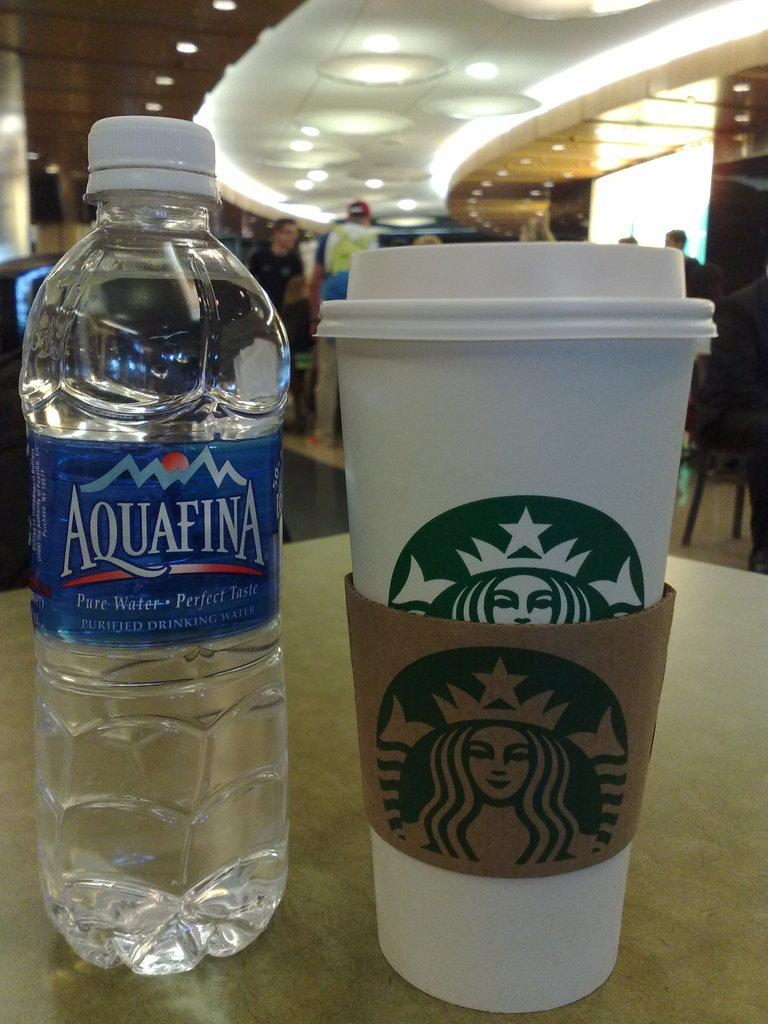Provide a one-sentence caption for the provided image. Starbucks coffee cup next to an Aquafina water bottle. 